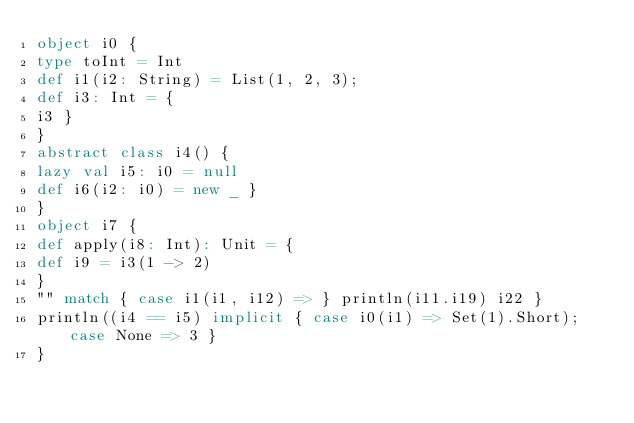<code> <loc_0><loc_0><loc_500><loc_500><_Scala_>object i0 {
type toInt = Int
def i1(i2: String) = List(1, 2, 3);
def i3: Int = {
i3 }
}
abstract class i4() {
lazy val i5: i0 = null
def i6(i2: i0) = new _ }
}
object i7 {
def apply(i8: Int): Unit = {
def i9 = i3(1 -> 2)
}
"" match { case i1(i1, i12) => } println(i11.i19) i22 }
println((i4 == i5) implicit { case i0(i1) => Set(1).Short); case None => 3 }
}</code> 